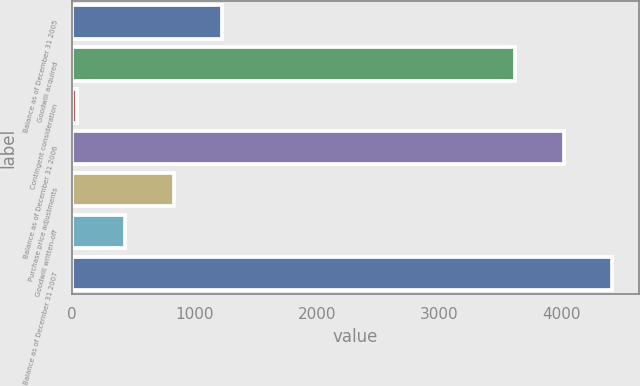Convert chart. <chart><loc_0><loc_0><loc_500><loc_500><bar_chart><fcel>Balance as of December 31 2005<fcel>Goodwill acquired<fcel>Contingent consideration<fcel>Balance as of December 31 2006<fcel>Purchase price adjustments<fcel>Goodwill written-off<fcel>Balance as of December 31 2007<nl><fcel>1226.1<fcel>3626<fcel>39<fcel>4021.7<fcel>830.4<fcel>434.7<fcel>4417.4<nl></chart> 